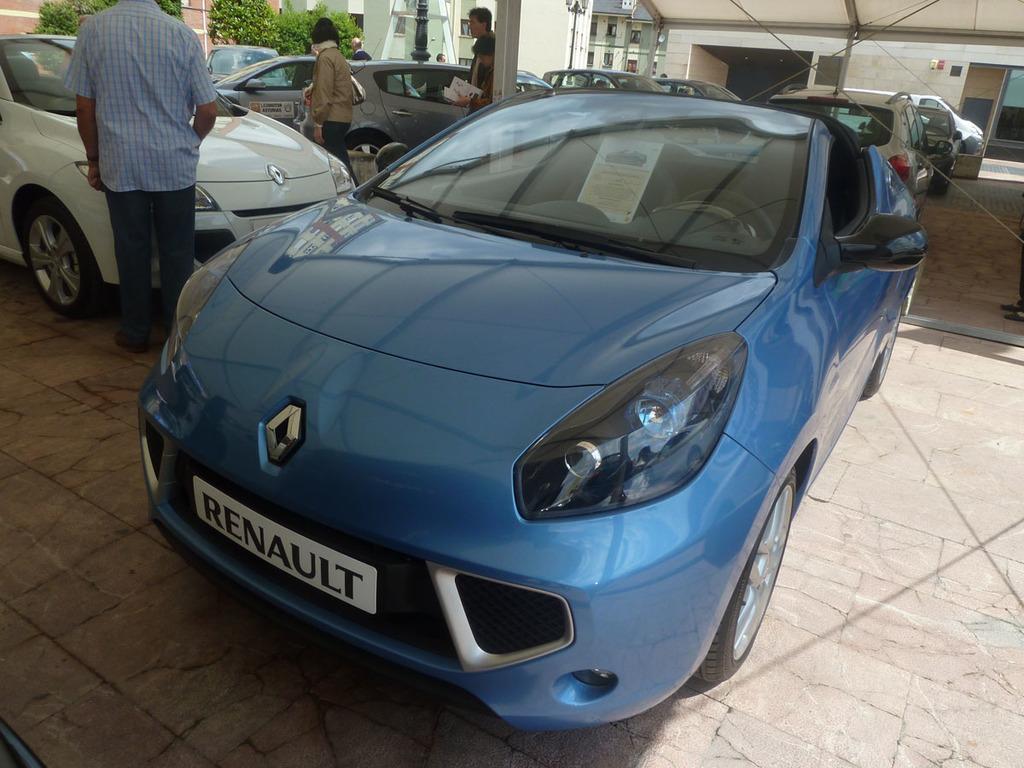Can you describe this image briefly? In this picture we can see a few vehicles on the path. There are a some people visible on the path. We can see a few plants and buildings in the background. 